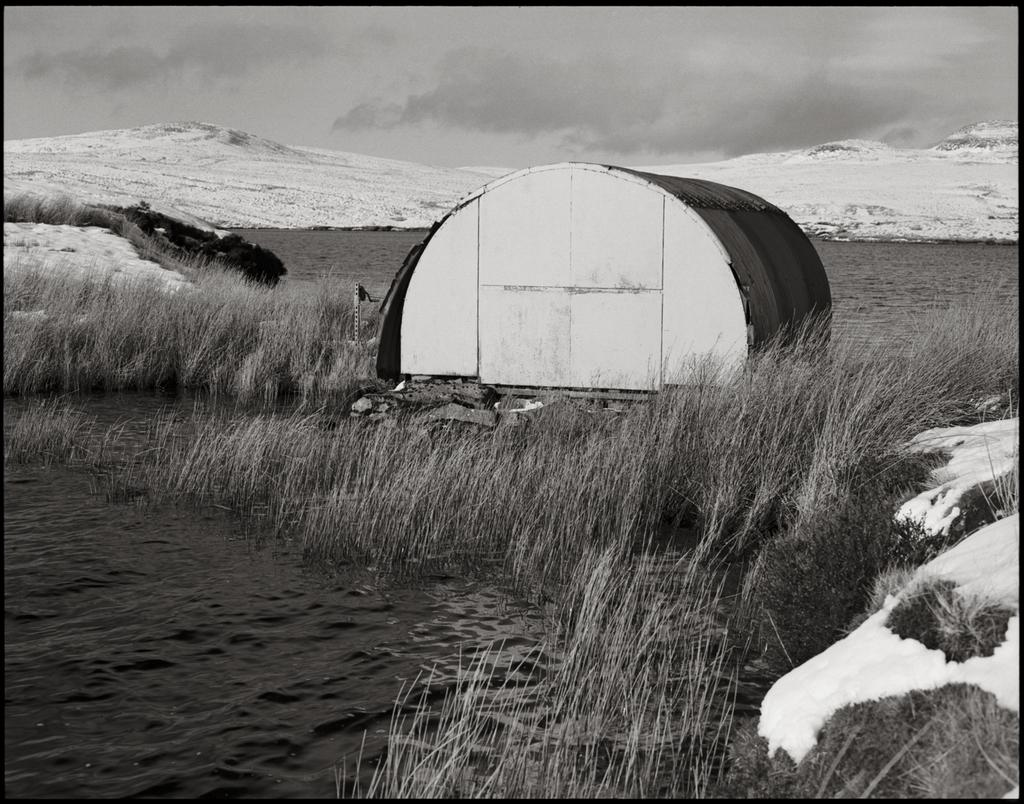What is the color scheme of the image? The image is black and white. What natural element can be seen in the image? There is water and grass in the image. What type of shelter is present in the image? There is a tent in the image. What type of weather condition is depicted in the image? There is snow in the image. What can be seen in the background of the image? There are mountains in the background of the image. What type of bear can be seen interacting with the invention in the image? There is no bear or invention present in the image. What rule is being enforced by the person in the image? There is no person or rule enforcement depicted in the image. 